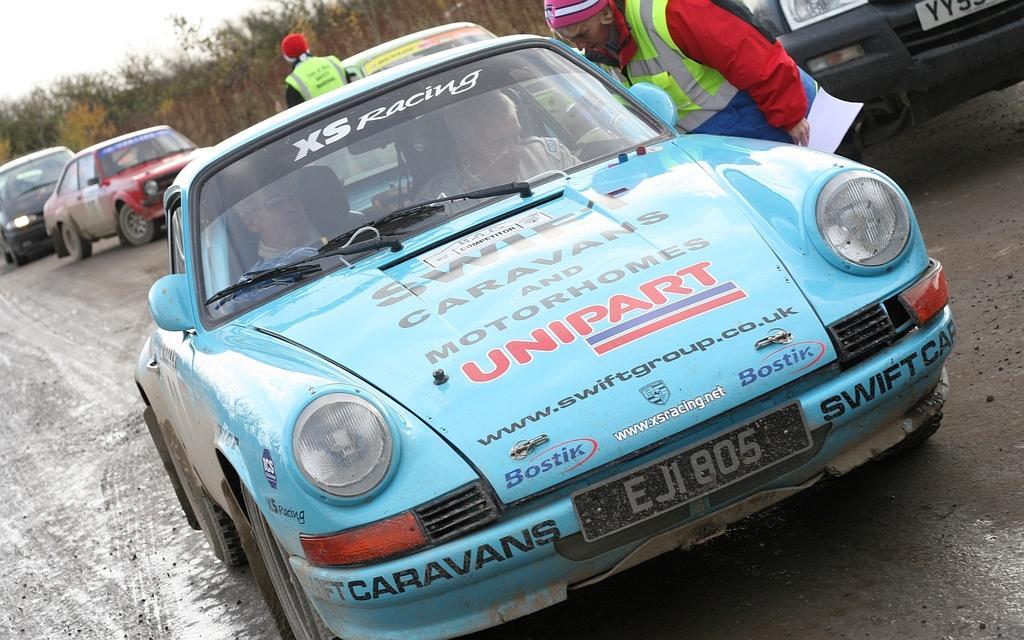Could you give a brief overview of what you see in this image? In this image in the foreground there is one car in the car there are two people sitting, and one person is standing beside the car and the person is holding papers and at the bottom there is road. In the background there are vehicles and some trees. 